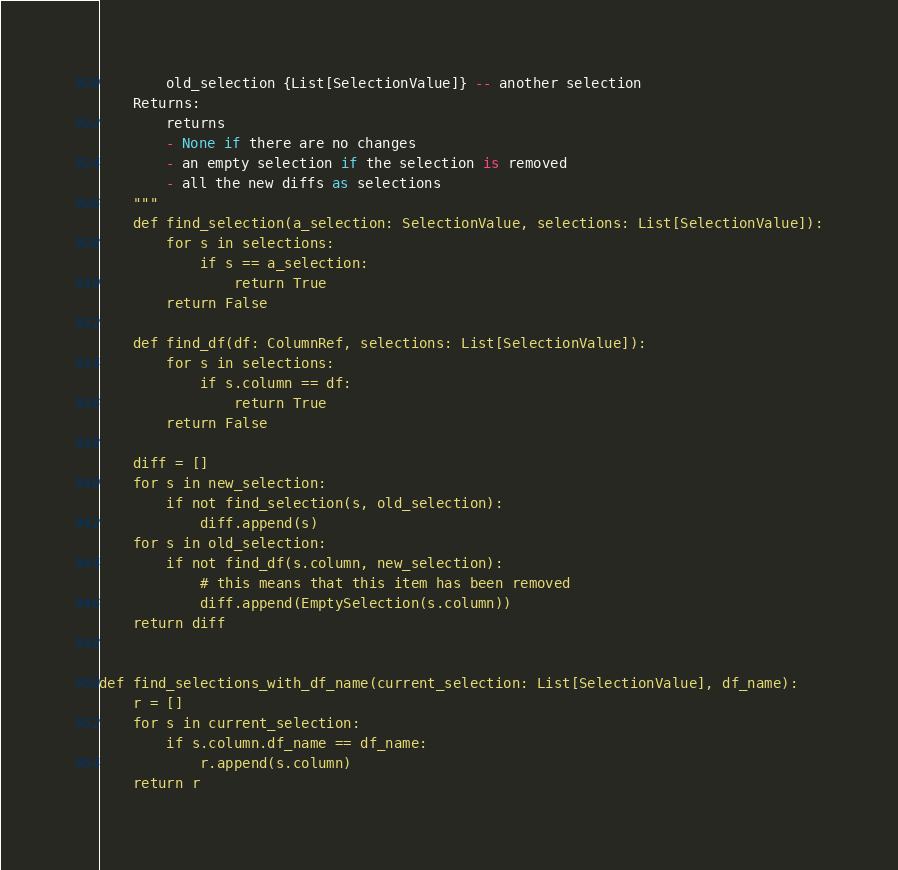<code> <loc_0><loc_0><loc_500><loc_500><_Python_>        old_selection {List[SelectionValue]} -- another selection
    Returns:
        returns
        - None if there are no changes
        - an empty selection if the selection is removed
        - all the new diffs as selections
    """
    def find_selection(a_selection: SelectionValue, selections: List[SelectionValue]):
        for s in selections:
            if s == a_selection:
                return True
        return False

    def find_df(df: ColumnRef, selections: List[SelectionValue]):
        for s in selections:
            if s.column == df:
                return True
        return False

    diff = []
    for s in new_selection:
        if not find_selection(s, old_selection):
            diff.append(s)
    for s in old_selection:
        if not find_df(s.column, new_selection):
            # this means that this item has been removed
            diff.append(EmptySelection(s.column))
    return diff


def find_selections_with_df_name(current_selection: List[SelectionValue], df_name):
    r = []
    for s in current_selection:
        if s.column.df_name == df_name:
            r.append(s.column)
    return r
</code> 